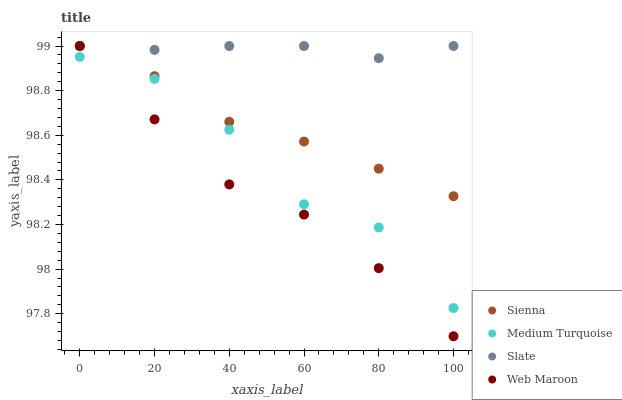Does Web Maroon have the minimum area under the curve?
Answer yes or no. Yes. Does Slate have the maximum area under the curve?
Answer yes or no. Yes. Does Slate have the minimum area under the curve?
Answer yes or no. No. Does Web Maroon have the maximum area under the curve?
Answer yes or no. No. Is Slate the smoothest?
Answer yes or no. Yes. Is Medium Turquoise the roughest?
Answer yes or no. Yes. Is Web Maroon the smoothest?
Answer yes or no. No. Is Web Maroon the roughest?
Answer yes or no. No. Does Web Maroon have the lowest value?
Answer yes or no. Yes. Does Slate have the lowest value?
Answer yes or no. No. Does Web Maroon have the highest value?
Answer yes or no. Yes. Does Medium Turquoise have the highest value?
Answer yes or no. No. Is Medium Turquoise less than Sienna?
Answer yes or no. Yes. Is Slate greater than Medium Turquoise?
Answer yes or no. Yes. Does Medium Turquoise intersect Web Maroon?
Answer yes or no. Yes. Is Medium Turquoise less than Web Maroon?
Answer yes or no. No. Is Medium Turquoise greater than Web Maroon?
Answer yes or no. No. Does Medium Turquoise intersect Sienna?
Answer yes or no. No. 